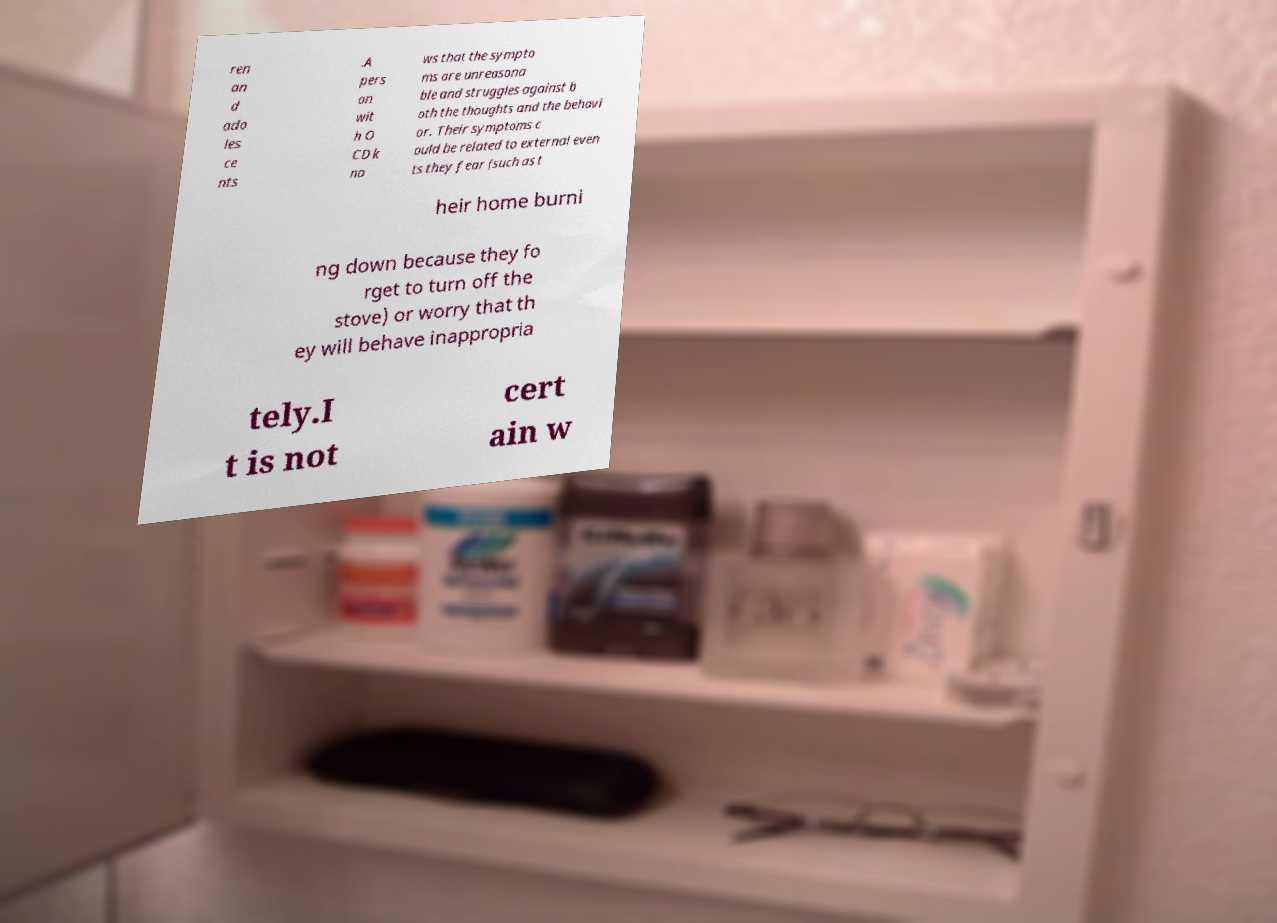There's text embedded in this image that I need extracted. Can you transcribe it verbatim? ren an d ado les ce nts .A pers on wit h O CD k no ws that the sympto ms are unreasona ble and struggles against b oth the thoughts and the behavi or. Their symptoms c ould be related to external even ts they fear (such as t heir home burni ng down because they fo rget to turn off the stove) or worry that th ey will behave inappropria tely.I t is not cert ain w 